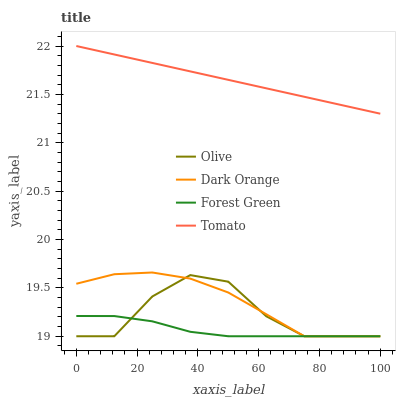Does Forest Green have the minimum area under the curve?
Answer yes or no. Yes. Does Tomato have the maximum area under the curve?
Answer yes or no. Yes. Does Dark Orange have the minimum area under the curve?
Answer yes or no. No. Does Dark Orange have the maximum area under the curve?
Answer yes or no. No. Is Tomato the smoothest?
Answer yes or no. Yes. Is Olive the roughest?
Answer yes or no. Yes. Is Dark Orange the smoothest?
Answer yes or no. No. Is Dark Orange the roughest?
Answer yes or no. No. Does Olive have the lowest value?
Answer yes or no. Yes. Does Tomato have the lowest value?
Answer yes or no. No. Does Tomato have the highest value?
Answer yes or no. Yes. Does Dark Orange have the highest value?
Answer yes or no. No. Is Olive less than Tomato?
Answer yes or no. Yes. Is Tomato greater than Forest Green?
Answer yes or no. Yes. Does Dark Orange intersect Olive?
Answer yes or no. Yes. Is Dark Orange less than Olive?
Answer yes or no. No. Is Dark Orange greater than Olive?
Answer yes or no. No. Does Olive intersect Tomato?
Answer yes or no. No. 